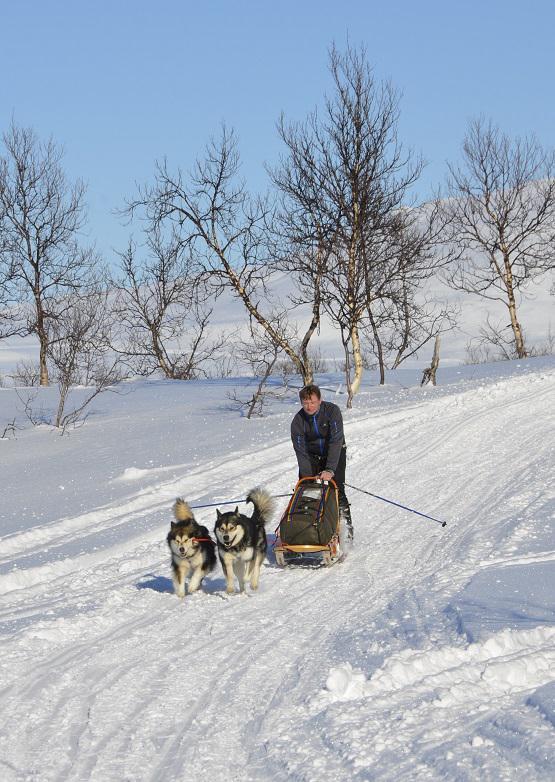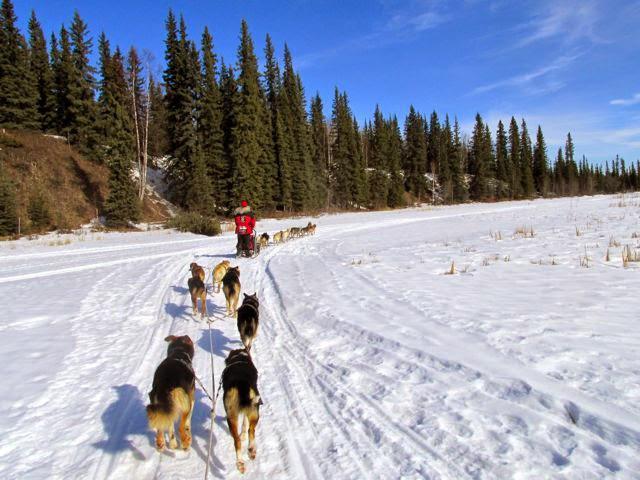The first image is the image on the left, the second image is the image on the right. Evaluate the accuracy of this statement regarding the images: "In at least one image there are at least five snow dogs leading a man in a red coat on the sled.". Is it true? Answer yes or no. Yes. The first image is the image on the left, the second image is the image on the right. Evaluate the accuracy of this statement regarding the images: "All dog sled teams are heading diagonally to the left with evergreen trees in the background.". Is it true? Answer yes or no. No. 